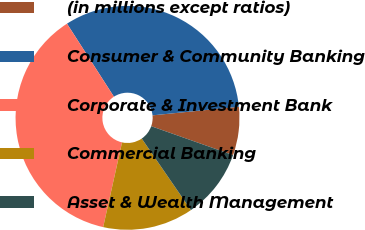Convert chart to OTSL. <chart><loc_0><loc_0><loc_500><loc_500><pie_chart><fcel>(in millions except ratios)<fcel>Consumer & Community Banking<fcel>Corporate & Investment Bank<fcel>Commercial Banking<fcel>Asset & Wealth Management<nl><fcel>6.98%<fcel>32.51%<fcel>37.42%<fcel>13.07%<fcel>10.02%<nl></chart> 